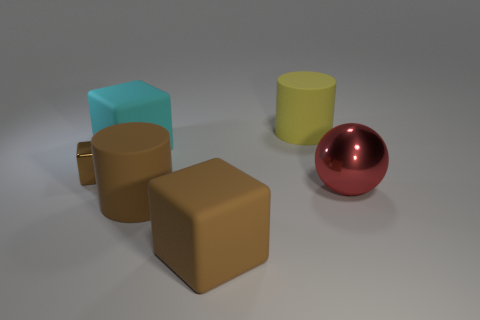Is there any other thing that has the same size as the brown metallic block?
Ensure brevity in your answer.  No. There is a large cube in front of the red metallic ball; how many big cylinders are on the right side of it?
Your answer should be compact. 1. Is the size of the brown thing that is in front of the brown cylinder the same as the tiny shiny thing?
Your answer should be very brief. No. What number of brown things are the same shape as the large cyan matte thing?
Give a very brief answer. 2. What is the shape of the red shiny thing?
Offer a very short reply. Sphere. Are there the same number of big matte cubes that are to the right of the yellow rubber cylinder and brown shiny objects?
Your answer should be compact. No. Are there any other things that have the same material as the red object?
Offer a very short reply. Yes. Is the large block that is in front of the small brown object made of the same material as the cyan object?
Provide a succinct answer. Yes. Is the number of cyan blocks that are behind the big yellow rubber cylinder less than the number of big matte cylinders?
Offer a very short reply. Yes. How many shiny objects are either small brown blocks or big objects?
Make the answer very short. 2. 